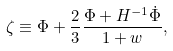<formula> <loc_0><loc_0><loc_500><loc_500>\zeta \equiv \Phi + \frac { 2 } { 3 } \frac { \Phi + H ^ { - 1 } \dot { \Phi } } { 1 + w } ,</formula> 